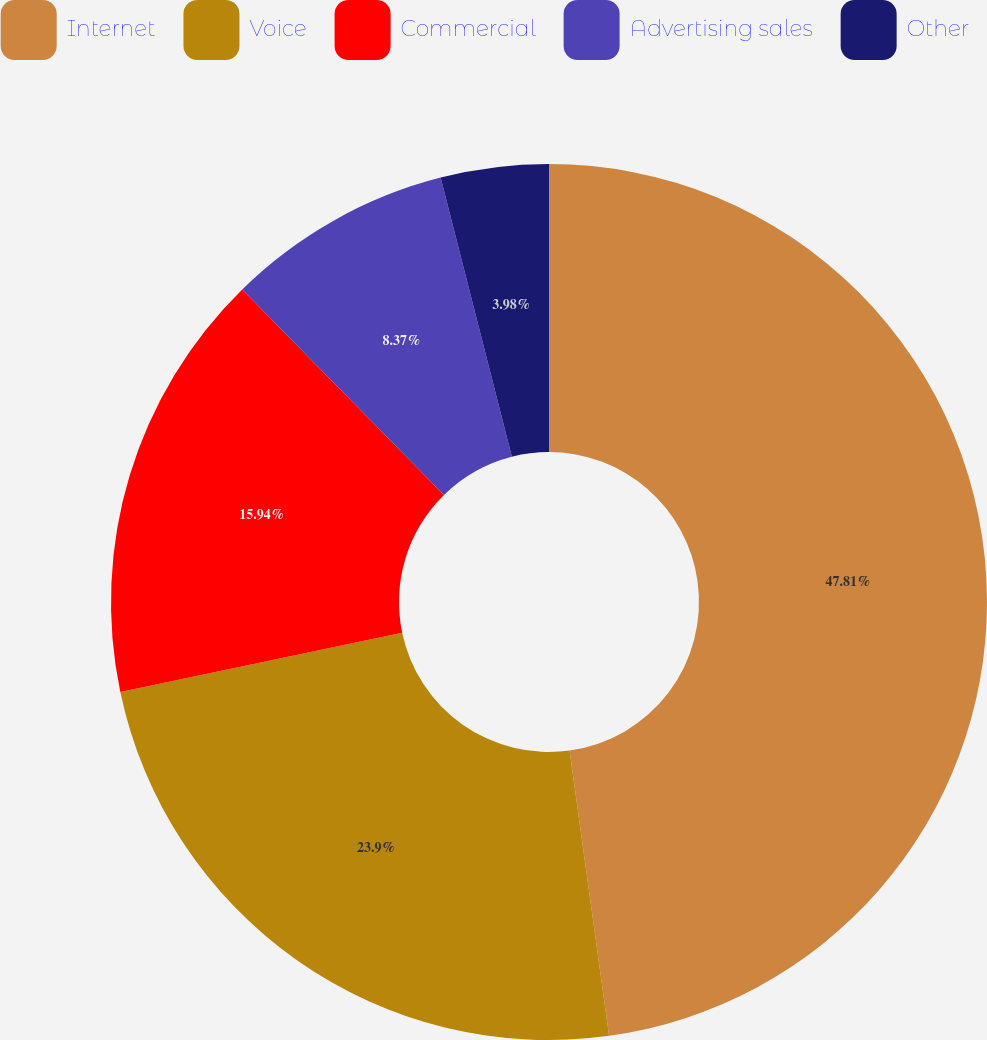<chart> <loc_0><loc_0><loc_500><loc_500><pie_chart><fcel>Internet<fcel>Voice<fcel>Commercial<fcel>Advertising sales<fcel>Other<nl><fcel>47.81%<fcel>23.9%<fcel>15.94%<fcel>8.37%<fcel>3.98%<nl></chart> 